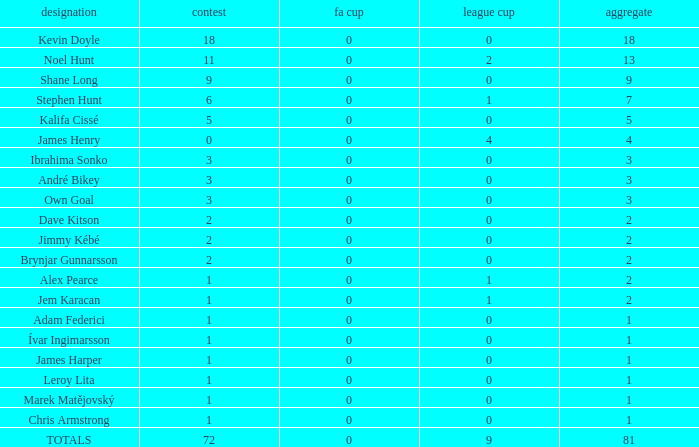What is the championship of Jem Karacan that has a total of 2 and a league cup more than 0? 1.0. 